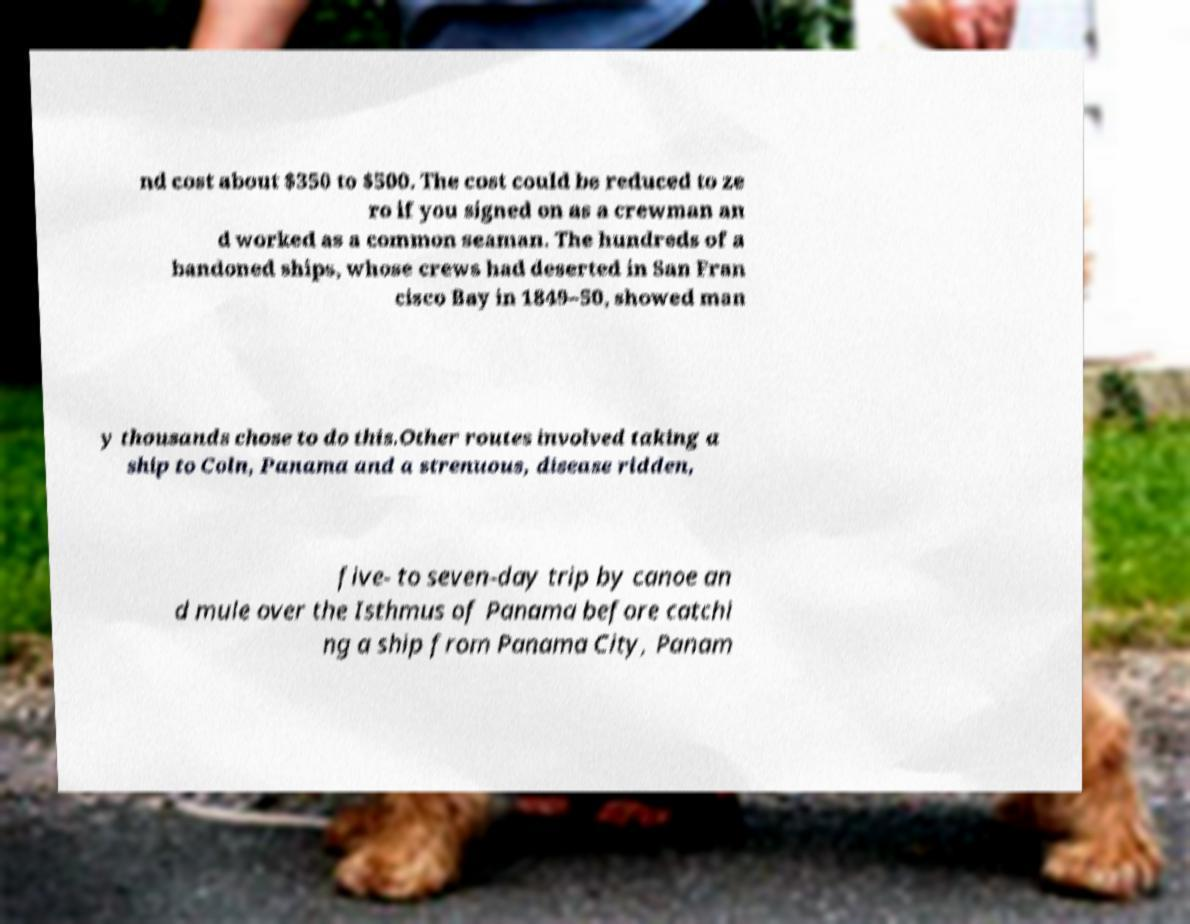Could you extract and type out the text from this image? nd cost about $350 to $500. The cost could be reduced to ze ro if you signed on as a crewman an d worked as a common seaman. The hundreds of a bandoned ships, whose crews had deserted in San Fran cisco Bay in 1849–50, showed man y thousands chose to do this.Other routes involved taking a ship to Coln, Panama and a strenuous, disease ridden, five- to seven-day trip by canoe an d mule over the Isthmus of Panama before catchi ng a ship from Panama City, Panam 